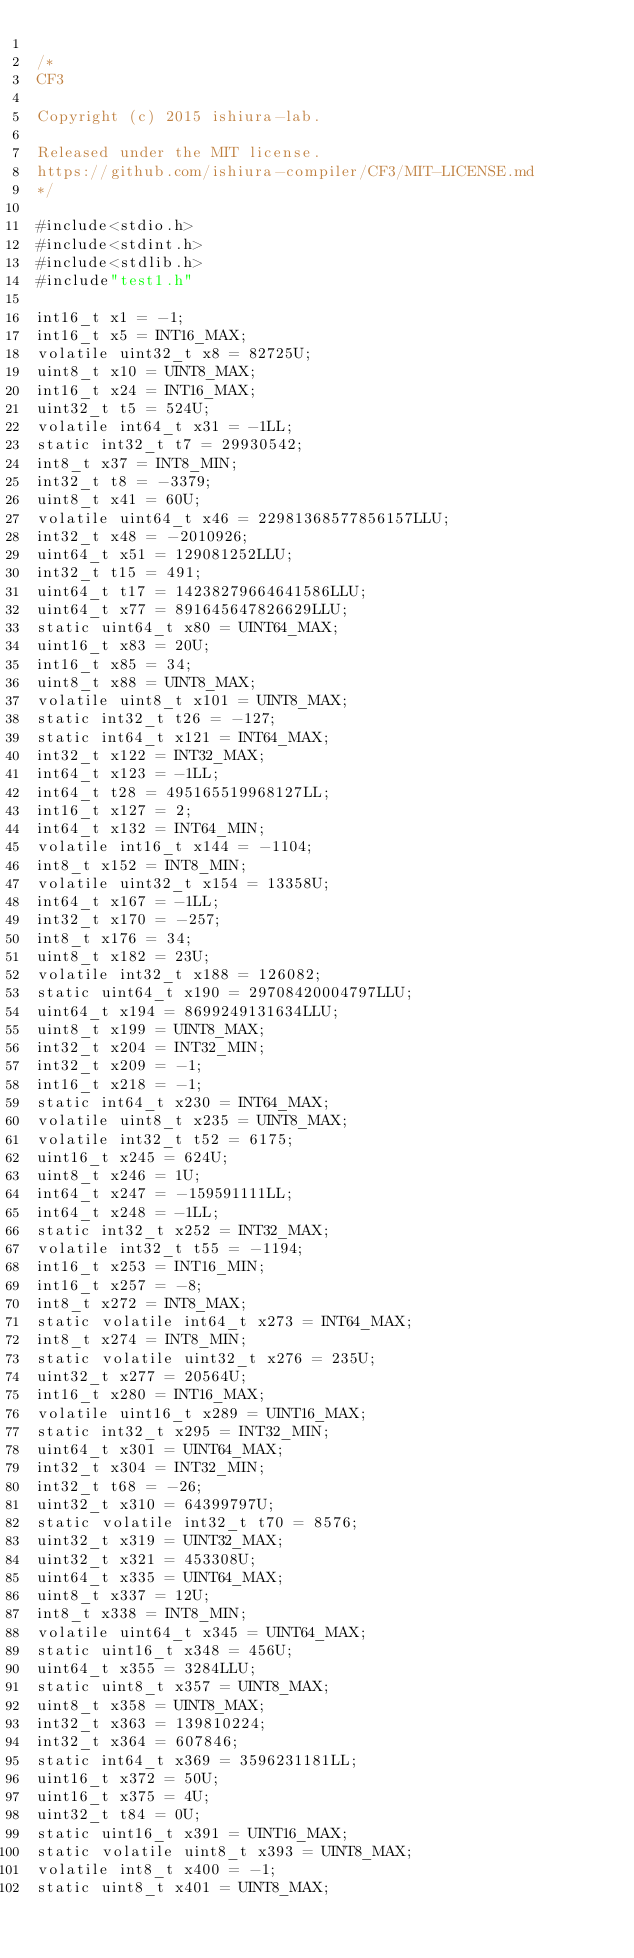Convert code to text. <code><loc_0><loc_0><loc_500><loc_500><_C_>
/*
CF3

Copyright (c) 2015 ishiura-lab.

Released under the MIT license.  
https://github.com/ishiura-compiler/CF3/MIT-LICENSE.md
*/

#include<stdio.h>
#include<stdint.h>
#include<stdlib.h>
#include"test1.h"

int16_t x1 = -1;
int16_t x5 = INT16_MAX;
volatile uint32_t x8 = 82725U;
uint8_t x10 = UINT8_MAX;
int16_t x24 = INT16_MAX;
uint32_t t5 = 524U;
volatile int64_t x31 = -1LL;
static int32_t t7 = 29930542;
int8_t x37 = INT8_MIN;
int32_t t8 = -3379;
uint8_t x41 = 60U;
volatile uint64_t x46 = 22981368577856157LLU;
int32_t x48 = -2010926;
uint64_t x51 = 129081252LLU;
int32_t t15 = 491;
uint64_t t17 = 14238279664641586LLU;
uint64_t x77 = 891645647826629LLU;
static uint64_t x80 = UINT64_MAX;
uint16_t x83 = 20U;
int16_t x85 = 34;
uint8_t x88 = UINT8_MAX;
volatile uint8_t x101 = UINT8_MAX;
static int32_t t26 = -127;
static int64_t x121 = INT64_MAX;
int32_t x122 = INT32_MAX;
int64_t x123 = -1LL;
int64_t t28 = 495165519968127LL;
int16_t x127 = 2;
int64_t x132 = INT64_MIN;
volatile int16_t x144 = -1104;
int8_t x152 = INT8_MIN;
volatile uint32_t x154 = 13358U;
int64_t x167 = -1LL;
int32_t x170 = -257;
int8_t x176 = 34;
uint8_t x182 = 23U;
volatile int32_t x188 = 126082;
static uint64_t x190 = 29708420004797LLU;
uint64_t x194 = 8699249131634LLU;
uint8_t x199 = UINT8_MAX;
int32_t x204 = INT32_MIN;
int32_t x209 = -1;
int16_t x218 = -1;
static int64_t x230 = INT64_MAX;
volatile uint8_t x235 = UINT8_MAX;
volatile int32_t t52 = 6175;
uint16_t x245 = 624U;
uint8_t x246 = 1U;
int64_t x247 = -159591111LL;
int64_t x248 = -1LL;
static int32_t x252 = INT32_MAX;
volatile int32_t t55 = -1194;
int16_t x253 = INT16_MIN;
int16_t x257 = -8;
int8_t x272 = INT8_MAX;
static volatile int64_t x273 = INT64_MAX;
int8_t x274 = INT8_MIN;
static volatile uint32_t x276 = 235U;
uint32_t x277 = 20564U;
int16_t x280 = INT16_MAX;
volatile uint16_t x289 = UINT16_MAX;
static int32_t x295 = INT32_MIN;
uint64_t x301 = UINT64_MAX;
int32_t x304 = INT32_MIN;
int32_t t68 = -26;
uint32_t x310 = 64399797U;
static volatile int32_t t70 = 8576;
uint32_t x319 = UINT32_MAX;
uint32_t x321 = 453308U;
uint64_t x335 = UINT64_MAX;
uint8_t x337 = 12U;
int8_t x338 = INT8_MIN;
volatile uint64_t x345 = UINT64_MAX;
static uint16_t x348 = 456U;
uint64_t x355 = 3284LLU;
static uint8_t x357 = UINT8_MAX;
uint8_t x358 = UINT8_MAX;
int32_t x363 = 139810224;
int32_t x364 = 607846;
static int64_t x369 = 3596231181LL;
uint16_t x372 = 50U;
uint16_t x375 = 4U;
uint32_t t84 = 0U;
static uint16_t x391 = UINT16_MAX;
static volatile uint8_t x393 = UINT8_MAX;
volatile int8_t x400 = -1;
static uint8_t x401 = UINT8_MAX;</code> 